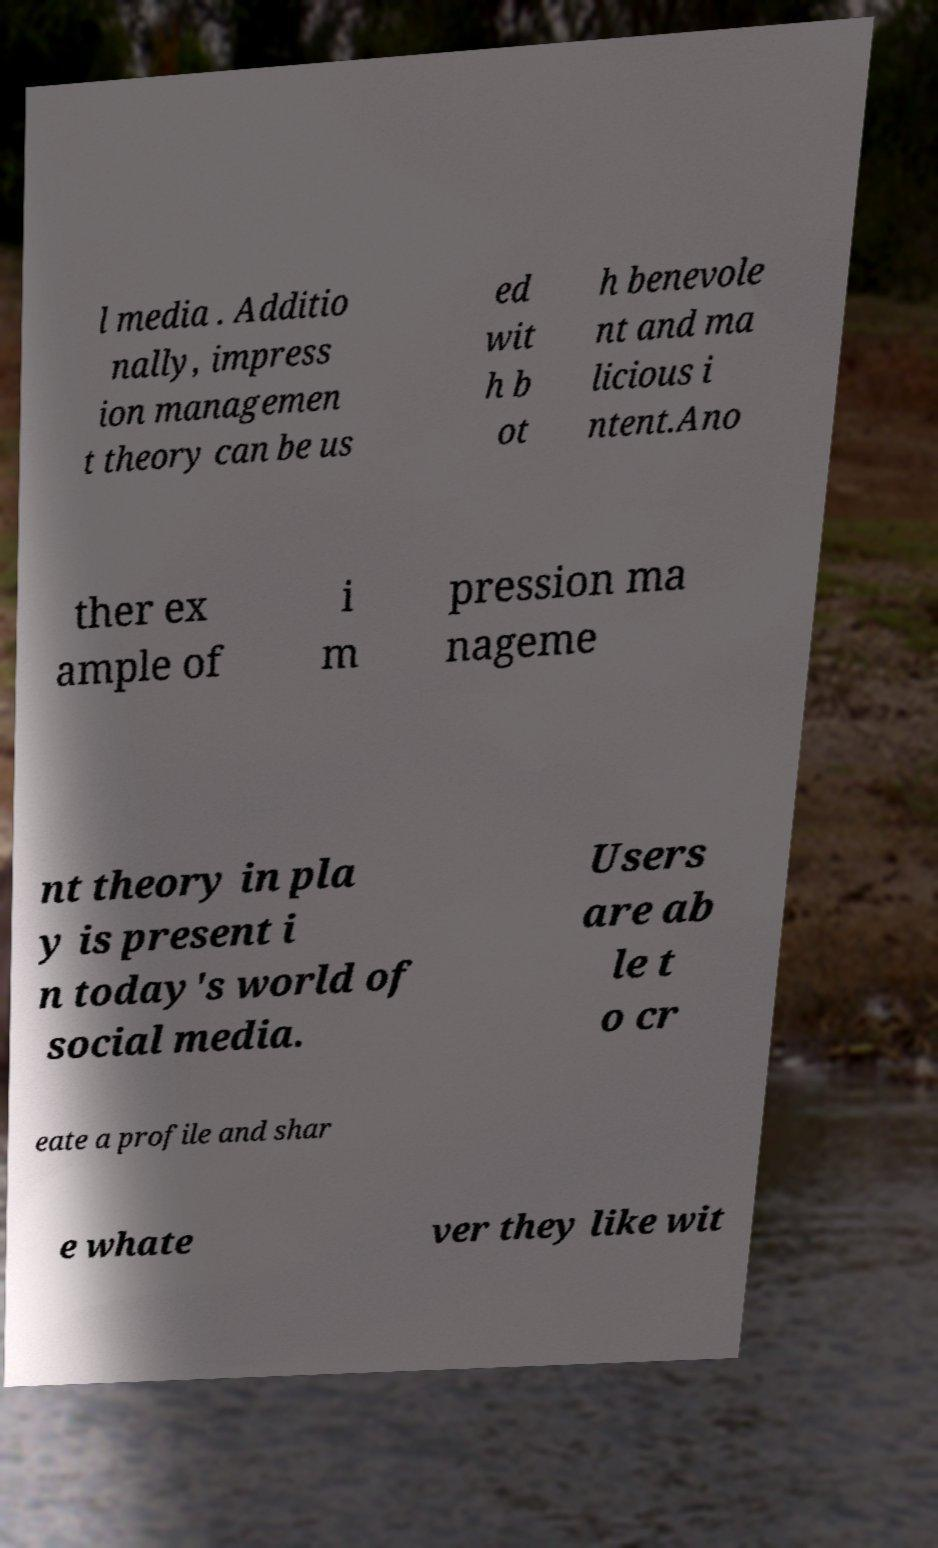I need the written content from this picture converted into text. Can you do that? l media . Additio nally, impress ion managemen t theory can be us ed wit h b ot h benevole nt and ma licious i ntent.Ano ther ex ample of i m pression ma nageme nt theory in pla y is present i n today's world of social media. Users are ab le t o cr eate a profile and shar e whate ver they like wit 